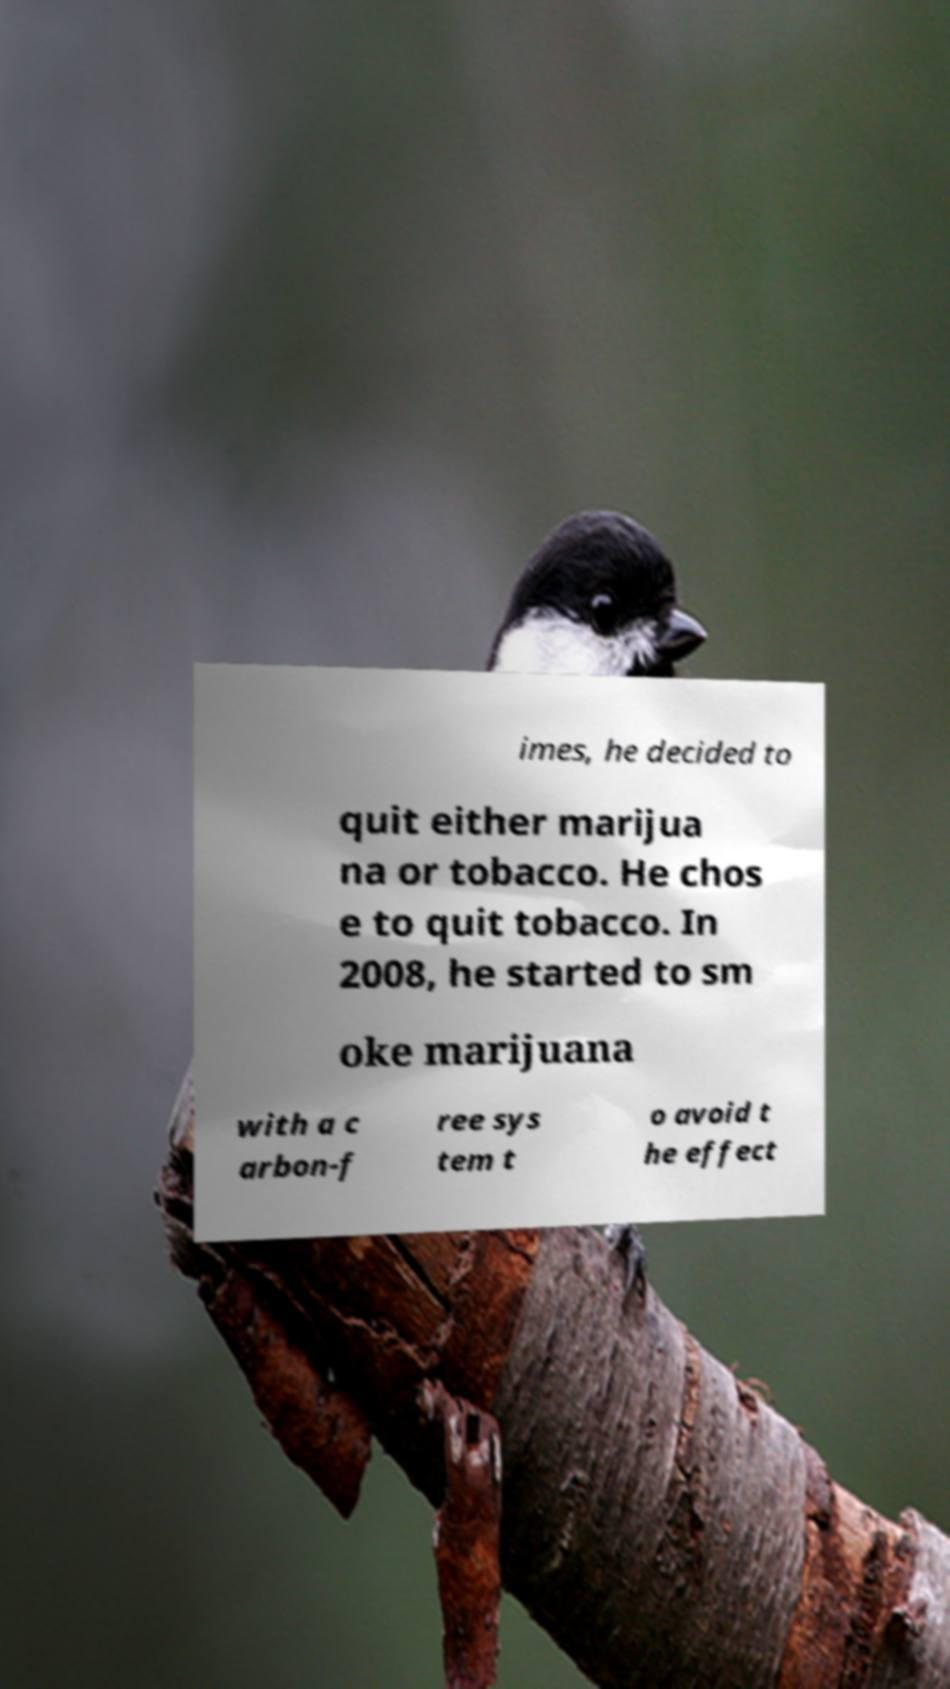Can you read and provide the text displayed in the image?This photo seems to have some interesting text. Can you extract and type it out for me? imes, he decided to quit either marijua na or tobacco. He chos e to quit tobacco. In 2008, he started to sm oke marijuana with a c arbon-f ree sys tem t o avoid t he effect 